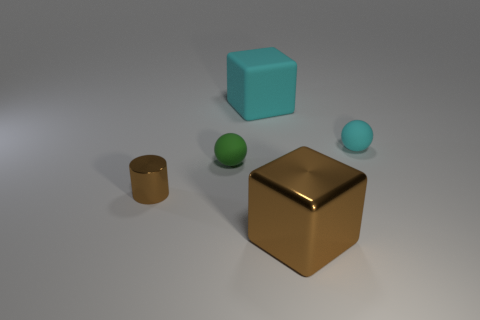Does the cylinder have the same color as the big shiny block?
Offer a terse response. Yes. There is another matte sphere that is the same size as the cyan sphere; what is its color?
Your answer should be very brief. Green. What number of metallic objects are either small green objects or large yellow objects?
Make the answer very short. 0. What is the color of the other sphere that is made of the same material as the small cyan sphere?
Offer a very short reply. Green. What is the material of the block on the left side of the thing in front of the small metal cylinder?
Give a very brief answer. Rubber. What number of objects are either tiny matte things that are in front of the small cyan rubber thing or cyan rubber objects that are on the left side of the big brown block?
Your response must be concise. 2. There is a block behind the small rubber object to the right of the brown thing that is to the right of the small green rubber ball; what is its size?
Make the answer very short. Large. Are there the same number of big brown cubes that are behind the big brown thing and cyan matte things?
Offer a very short reply. No. Is there any other thing that is the same shape as the large brown thing?
Provide a succinct answer. Yes. Is the shape of the tiny green matte object the same as the cyan thing left of the large brown shiny thing?
Provide a succinct answer. No. 